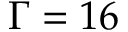Convert formula to latex. <formula><loc_0><loc_0><loc_500><loc_500>\Gamma = 1 6</formula> 